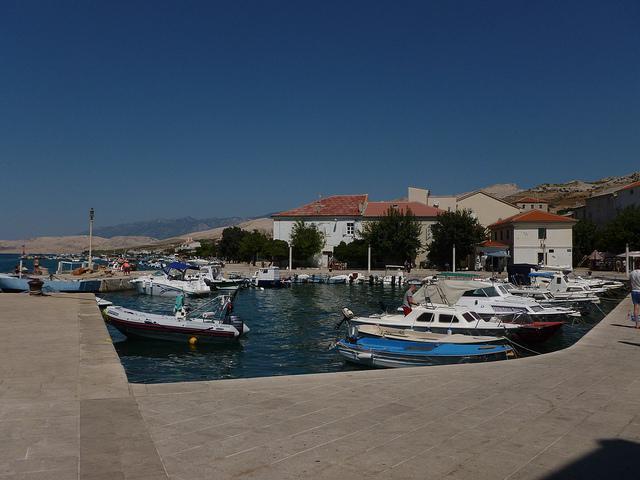What color is the top of the speed boat that is closest to the corner of the dock?
Make your selection and explain in format: 'Answer: answer
Rationale: rationale.'
Options: Orange, blue, white, tan. Answer: blue.
Rationale: It is a brighter shade of the same color as the water 